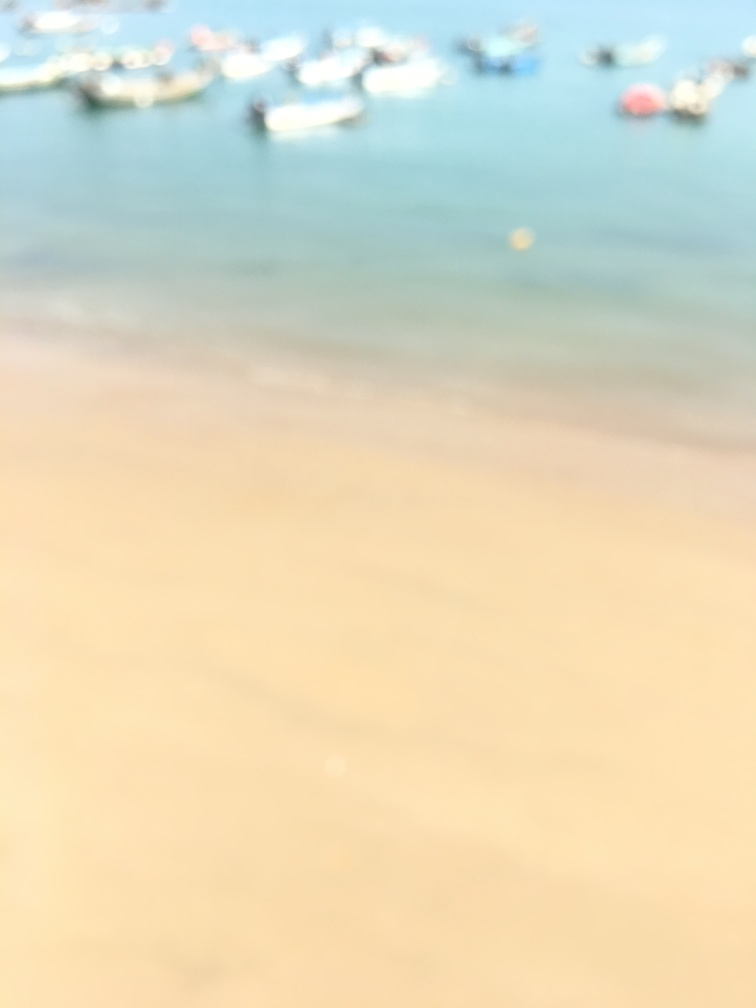If you had to guess, what do you think this image is trying to capture before it became blurred? Based on the shades of blue and tan hues in the image, it might be an attempt to capture a beach scene with boats in the water. The tan might represent the sandy shore, while the blue could suggest the presence of water and sky, possibly indicating a coastal landscape. 